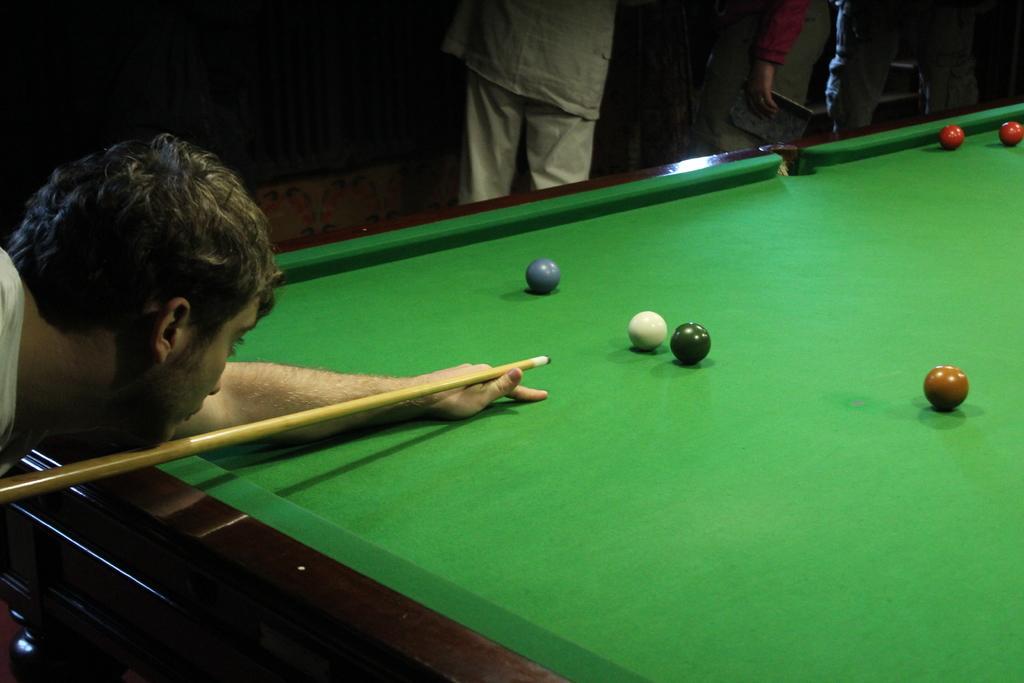How would you summarize this image in a sentence or two? In this image I can see a person is holding a stick in his hands which is cream in color. I can see a billiards table which is green in color and few balls on it. In the background I can see few other persons standing. 